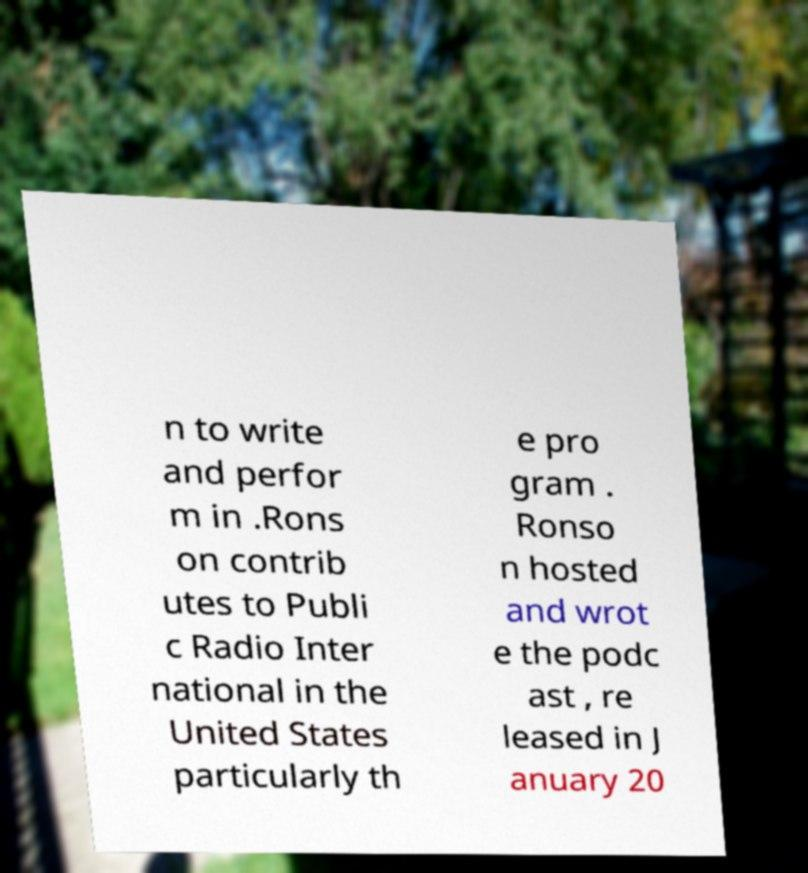I need the written content from this picture converted into text. Can you do that? n to write and perfor m in .Rons on contrib utes to Publi c Radio Inter national in the United States particularly th e pro gram . Ronso n hosted and wrot e the podc ast , re leased in J anuary 20 